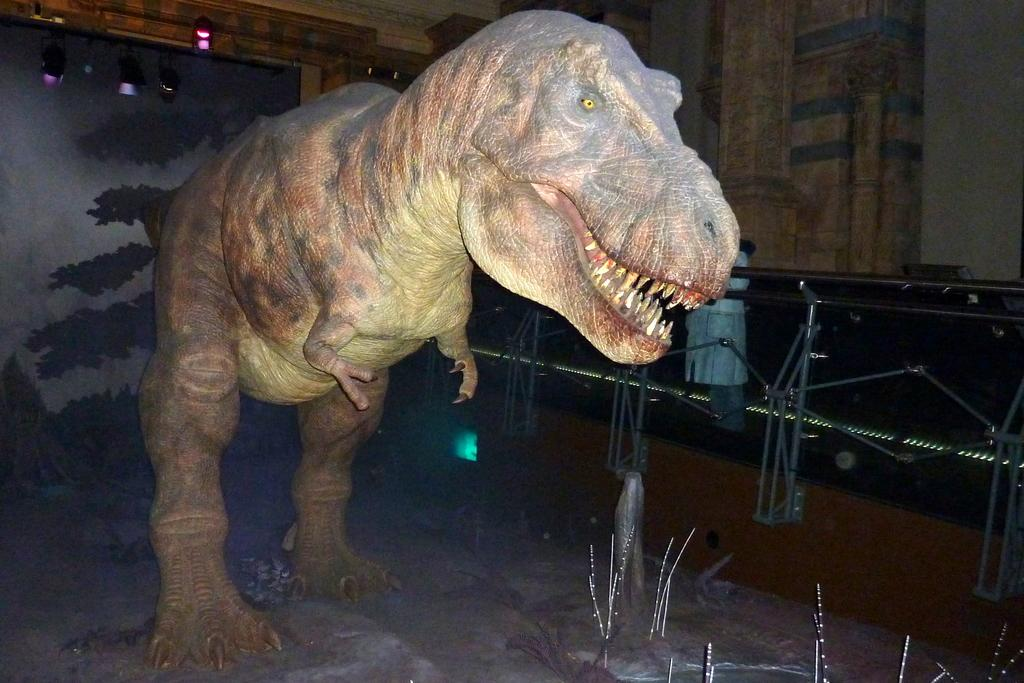What is the main subject of the image? There is a building model of a dinosaur in the image. What can be seen in the image besides the dinosaur model? There are grills and electric lights visible in the image. What type of structure is present in the image? There are walls in the image. What is the current amount of electricity being used by the electric lights in the image? There is no information provided about the amount of electricity being used by the electric lights in the image. 